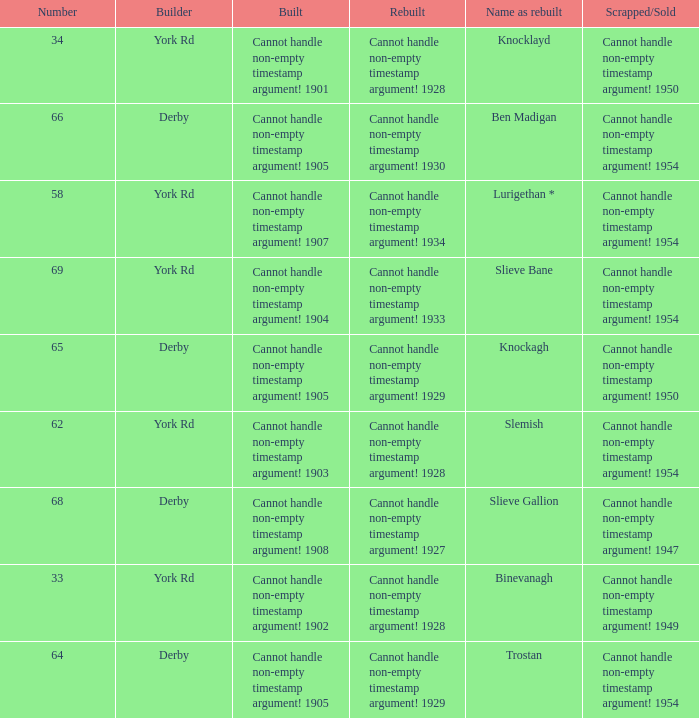Which Rebuilt has a Builder of derby, and a Name as rebuilt of ben madigan? Cannot handle non-empty timestamp argument! 1930. 